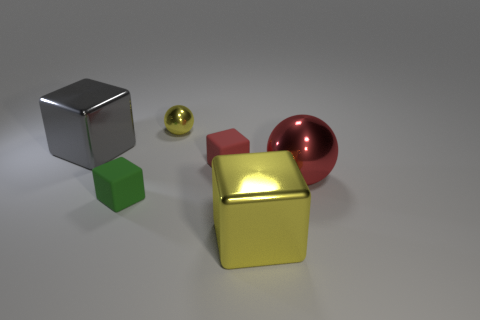Add 4 small cyan metal spheres. How many objects exist? 10 Subtract all spheres. How many objects are left? 4 Add 3 big objects. How many big objects exist? 6 Subtract 0 brown cylinders. How many objects are left? 6 Subtract all tiny green matte cylinders. Subtract all red metallic things. How many objects are left? 5 Add 5 small yellow things. How many small yellow things are left? 6 